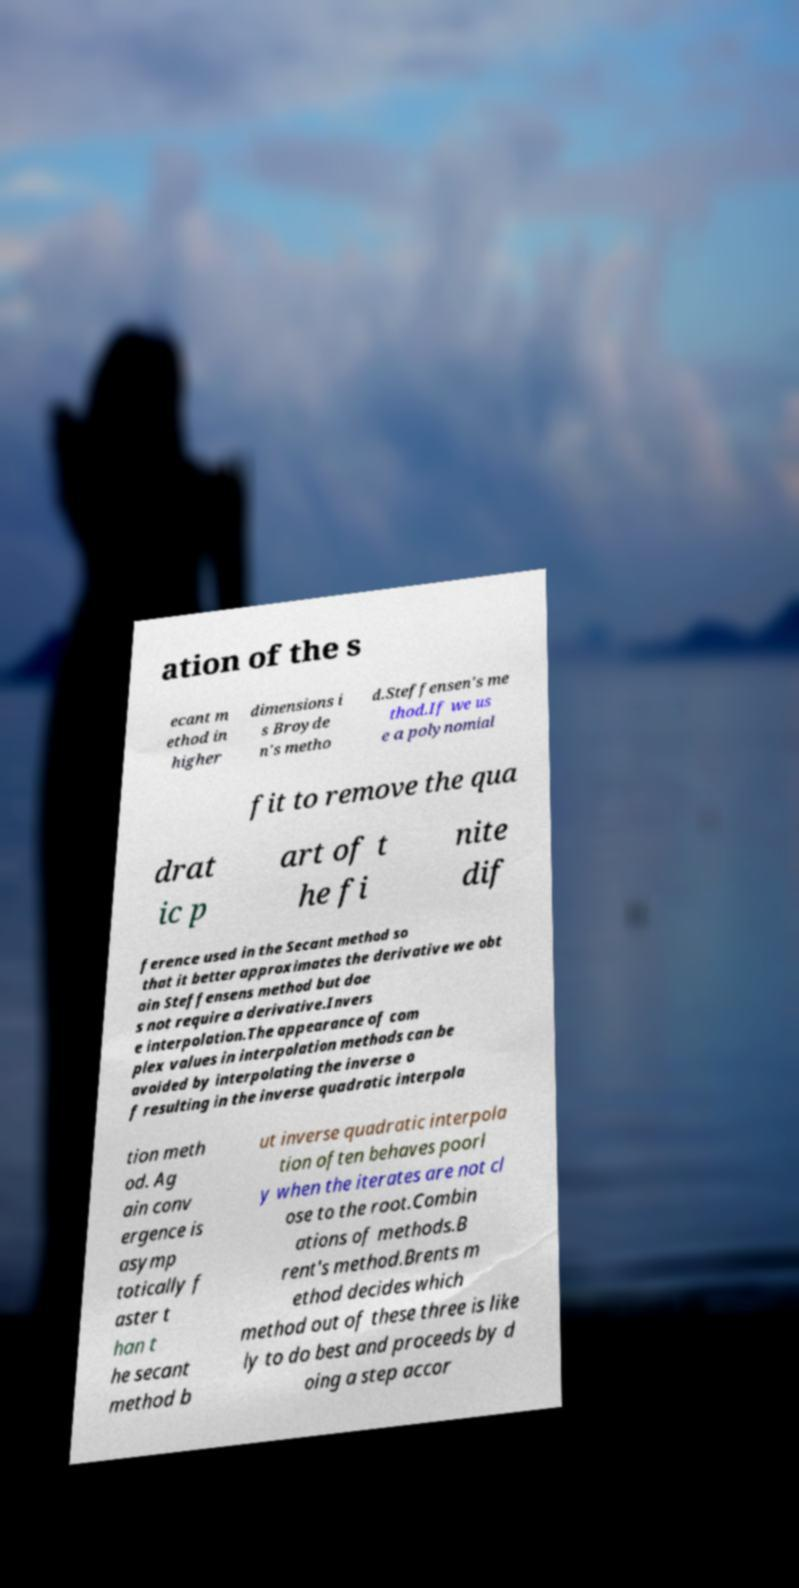There's text embedded in this image that I need extracted. Can you transcribe it verbatim? ation of the s ecant m ethod in higher dimensions i s Broyde n's metho d.Steffensen's me thod.If we us e a polynomial fit to remove the qua drat ic p art of t he fi nite dif ference used in the Secant method so that it better approximates the derivative we obt ain Steffensens method but doe s not require a derivative.Invers e interpolation.The appearance of com plex values in interpolation methods can be avoided by interpolating the inverse o f resulting in the inverse quadratic interpola tion meth od. Ag ain conv ergence is asymp totically f aster t han t he secant method b ut inverse quadratic interpola tion often behaves poorl y when the iterates are not cl ose to the root.Combin ations of methods.B rent's method.Brents m ethod decides which method out of these three is like ly to do best and proceeds by d oing a step accor 